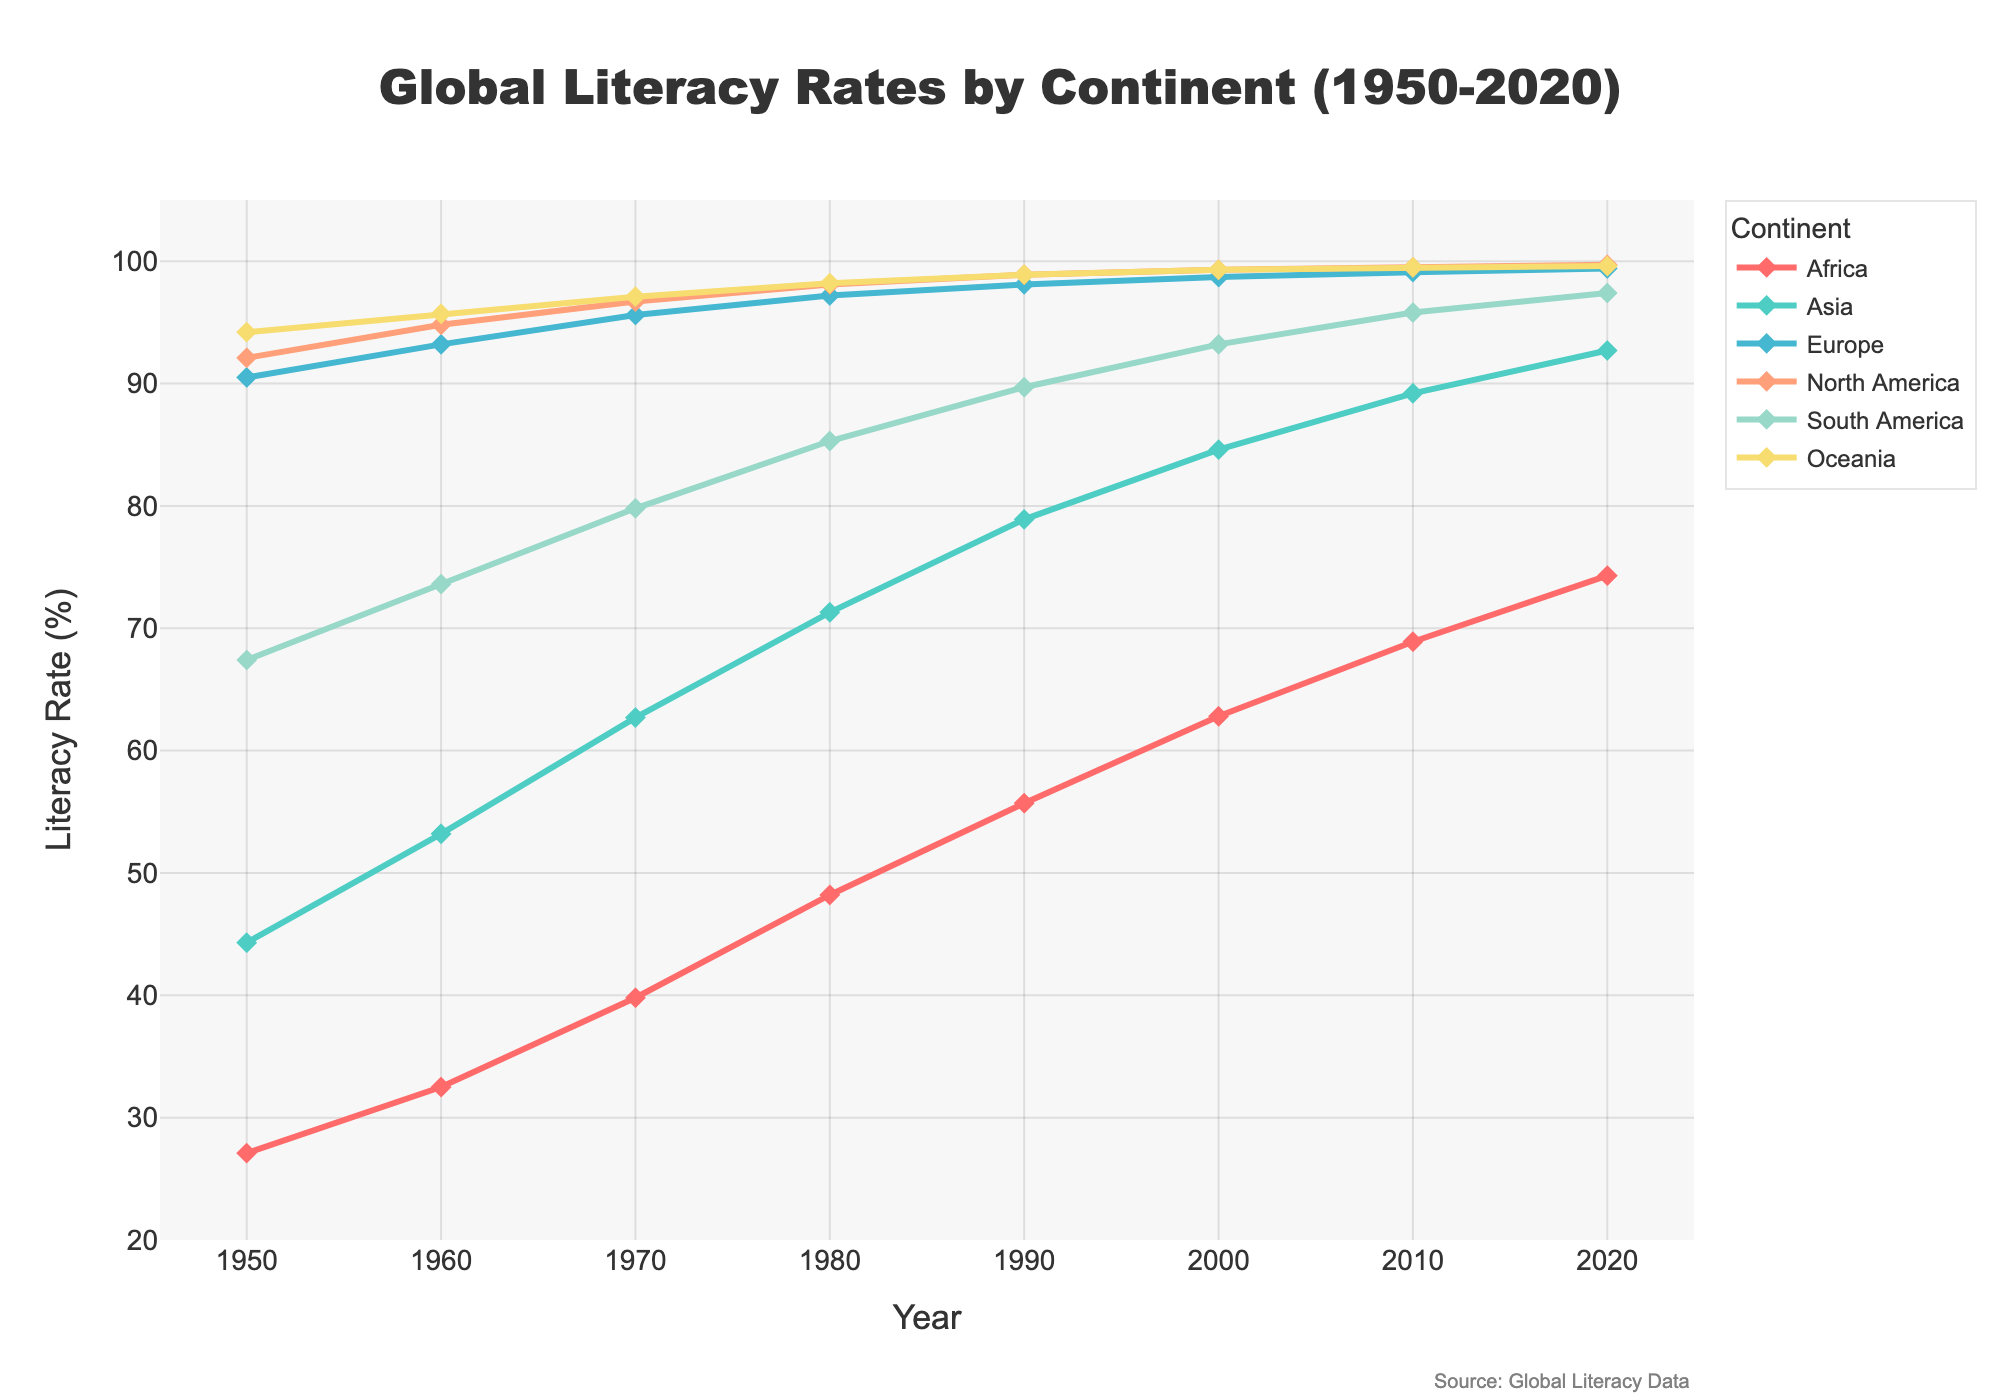What is the general trend of literacy rates in Africa from 1950 to 2020? The chart shows a steady increase in literacy rates in Africa from 27.1% in 1950 to 74.3% in 2020. This indicates a significant improvement over the 70-year span.
Answer: Steady increase Which continent had the highest literacy rate in 1950, and what was the value? In 1950, Oceania had the highest literacy rate at 94.2%, as indicated by the topmost line on the chart for this year.
Answer: Oceania, 94.2% By how much did the literacy rate in Asia increase from 1950 to 2020? The literacy rate in Asia increased from 44.3% in 1950 to 92.7% in 2020. The difference between these values is 92.7% - 44.3%, which equals 48.4%.
Answer: 48.4% Which continent showed the least improvement in literacy rates between 1950 and 2020? Europe had the smallest increase, going from 90.5% in 1950 to 99.4% in 2020. This is an increase of 8.9%, which is less than the improvements seen in other continents.
Answer: Europe Around which decade did North America achieve close to 100% literacy rate? North America’s literacy rate was around 99.3% in 2000. So, North America achieved close to 100% literacy rate around the decade of the 2000s, showing substantial growth before that time.
Answer: 2000s Compare the literacy rate of South America in 1970 with Europe in 1950. In 1970, South America's literacy rate was 79.8%, while Europe's literacy rate in 1950 was 90.5%. Europe had a higher literacy rate in 1950 compared to South America in 1970 by 10.7% (90.5% - 79.8%).
Answer: Europe; 10.7% higher What is the average literacy rate of Oceania from 1950 to 2020? The rates for Oceania are: 94.2, 95.7, 97.1, 98.2, 98.9, 99.3, 99.5, and 99.6. Summing these gives 782.5, and the average over 8 years is 782.5 / 8 = 97.81%.
Answer: 97.81% Identify the correlation between the years and the literacy rates in Asia. There is a positive correlation; as the years increase, the literacy rate in Asia also increases, going from 44.3% in 1950 to 92.7% in 2020.
Answer: Positive correlation What visual indicators show the rise in literacy rates globally? The consistent upward-sloping lines for each continent, combined with the markers on the lines, show an increase in literacy rates globally. There is no continent where the literacy rate decreases over time.
Answer: Upward-sloping lines and markers 